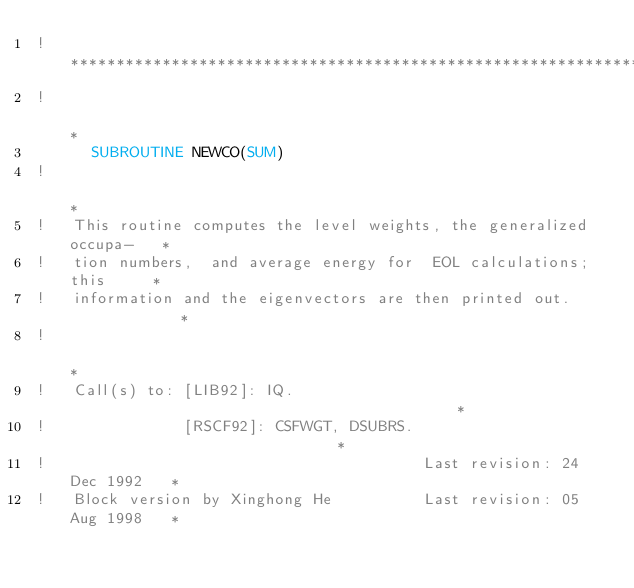Convert code to text. <code><loc_0><loc_0><loc_500><loc_500><_FORTRAN_>!***********************************************************************
!                                                                      *
      SUBROUTINE NEWCO(SUM)
!                                                                      *
!   This routine computes the level weights, the generalized occupa-   *
!   tion numbers,  and average energy for  EOL calculations;  this     *
!   information and the eigenvectors are then printed out.             *
!                                                                      *
!   Call(s) to: [LIB92]: IQ.                                           *
!               [RSCF92]: CSFWGT, DSUBRS.                              *
!                                         Last revision: 24 Dec 1992   *
!   Block version by Xinghong He          Last revision: 05 Aug 1998   *</code> 